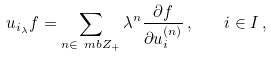Convert formula to latex. <formula><loc_0><loc_0><loc_500><loc_500>u _ { i _ { \lambda } } f = \sum _ { n \in \ m b Z _ { + } } \lambda ^ { n } \frac { \partial f } { \partial u _ { i } ^ { ( n ) } } \, , \quad i \in I \, ,</formula> 